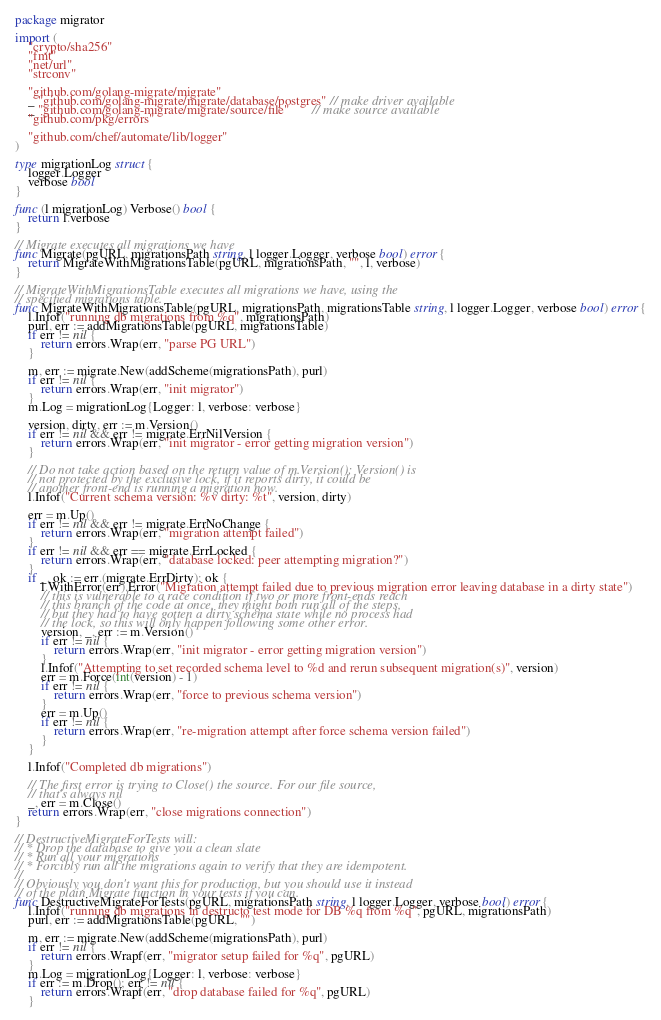Convert code to text. <code><loc_0><loc_0><loc_500><loc_500><_Go_>package migrator

import (
	"crypto/sha256"
	"fmt"
	"net/url"
	"strconv"

	"github.com/golang-migrate/migrate"
	_ "github.com/golang-migrate/migrate/database/postgres" // make driver available
	_ "github.com/golang-migrate/migrate/source/file"       // make source available
	"github.com/pkg/errors"

	"github.com/chef/automate/lib/logger"
)

type migrationLog struct {
	logger.Logger
	verbose bool
}

func (l migrationLog) Verbose() bool {
	return l.verbose
}

// Migrate executes all migrations we have
func Migrate(pgURL, migrationsPath string, l logger.Logger, verbose bool) error {
	return MigrateWithMigrationsTable(pgURL, migrationsPath, "", l, verbose)
}

// MigrateWithMigrationsTable executes all migrations we have, using the
// specified migrations table.
func MigrateWithMigrationsTable(pgURL, migrationsPath, migrationsTable string, l logger.Logger, verbose bool) error {
	l.Infof("running db migrations from %q", migrationsPath)
	purl, err := addMigrationsTable(pgURL, migrationsTable)
	if err != nil {
		return errors.Wrap(err, "parse PG URL")
	}

	m, err := migrate.New(addScheme(migrationsPath), purl)
	if err != nil {
		return errors.Wrap(err, "init migrator")
	}
	m.Log = migrationLog{Logger: l, verbose: verbose}

	version, dirty, err := m.Version()
	if err != nil && err != migrate.ErrNilVersion {
		return errors.Wrap(err, "init migrator - error getting migration version")
	}

	// Do not take action based on the return value of m.Version(); Version() is
	// not protected by the exclusive lock, if it reports dirty, it could be
	// another front-end is running a migration now.
	l.Infof("Current schema version: %v dirty: %t", version, dirty)

	err = m.Up()
	if err != nil && err != migrate.ErrNoChange {
		return errors.Wrap(err, "migration attempt failed")
	}
	if err != nil && err == migrate.ErrLocked {
		return errors.Wrap(err, "database locked: peer attempting migration?")
	}
	if _, ok := err.(migrate.ErrDirty); ok {
		l.WithError(err).Error("Migration attempt failed due to previous migration error leaving database in a dirty state")
		// this is vulnerable to a race condition if two or more front-ends reach
		// this branch of the code at once, they might both run all of the steps,
		// but they had to have gotten a dirty schema state while no process had
		// the lock, so this will only happen following some other error.
		version, _, err := m.Version()
		if err != nil {
			return errors.Wrap(err, "init migrator - error getting migration version")
		}
		l.Infof("Attempting to set recorded schema level to %d and rerun subsequent migration(s)", version)
		err = m.Force(int(version) - 1)
		if err != nil {
			return errors.Wrap(err, "force to previous schema version")
		}
		err = m.Up()
		if err != nil {
			return errors.Wrap(err, "re-migration attempt after force schema version failed")
		}
	}

	l.Infof("Completed db migrations")

	// The first error is trying to Close() the source. For our file source,
	// that's always nil
	_, err = m.Close()
	return errors.Wrap(err, "close migrations connection")
}

// DestructiveMigrateForTests will:
// * Drop the database to give you a clean slate
// * Run all your migrations
// * Forcibly run all the migrations again to verify that they are idempotent.
//
// Obviously you don't want this for production, but you should use it instead
// of the plain Migrate function in your tests if you can.
func DestructiveMigrateForTests(pgURL, migrationsPath string, l logger.Logger, verbose bool) error {
	l.Infof("running db migrations in destructo test mode for DB %q from %q", pgURL, migrationsPath)
	purl, err := addMigrationsTable(pgURL, "")

	m, err := migrate.New(addScheme(migrationsPath), purl)
	if err != nil {
		return errors.Wrapf(err, "migrator setup failed for %q", pgURL)
	}
	m.Log = migrationLog{Logger: l, verbose: verbose}
	if err := m.Drop(); err != nil {
		return errors.Wrapf(err, "drop database failed for %q", pgURL)
	}</code> 